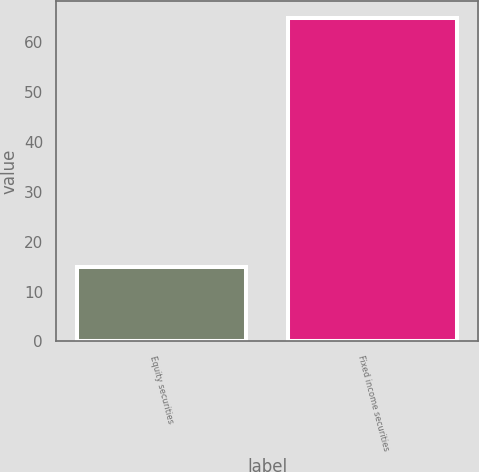<chart> <loc_0><loc_0><loc_500><loc_500><bar_chart><fcel>Equity securities<fcel>Fixed income securities<nl><fcel>15<fcel>65<nl></chart> 